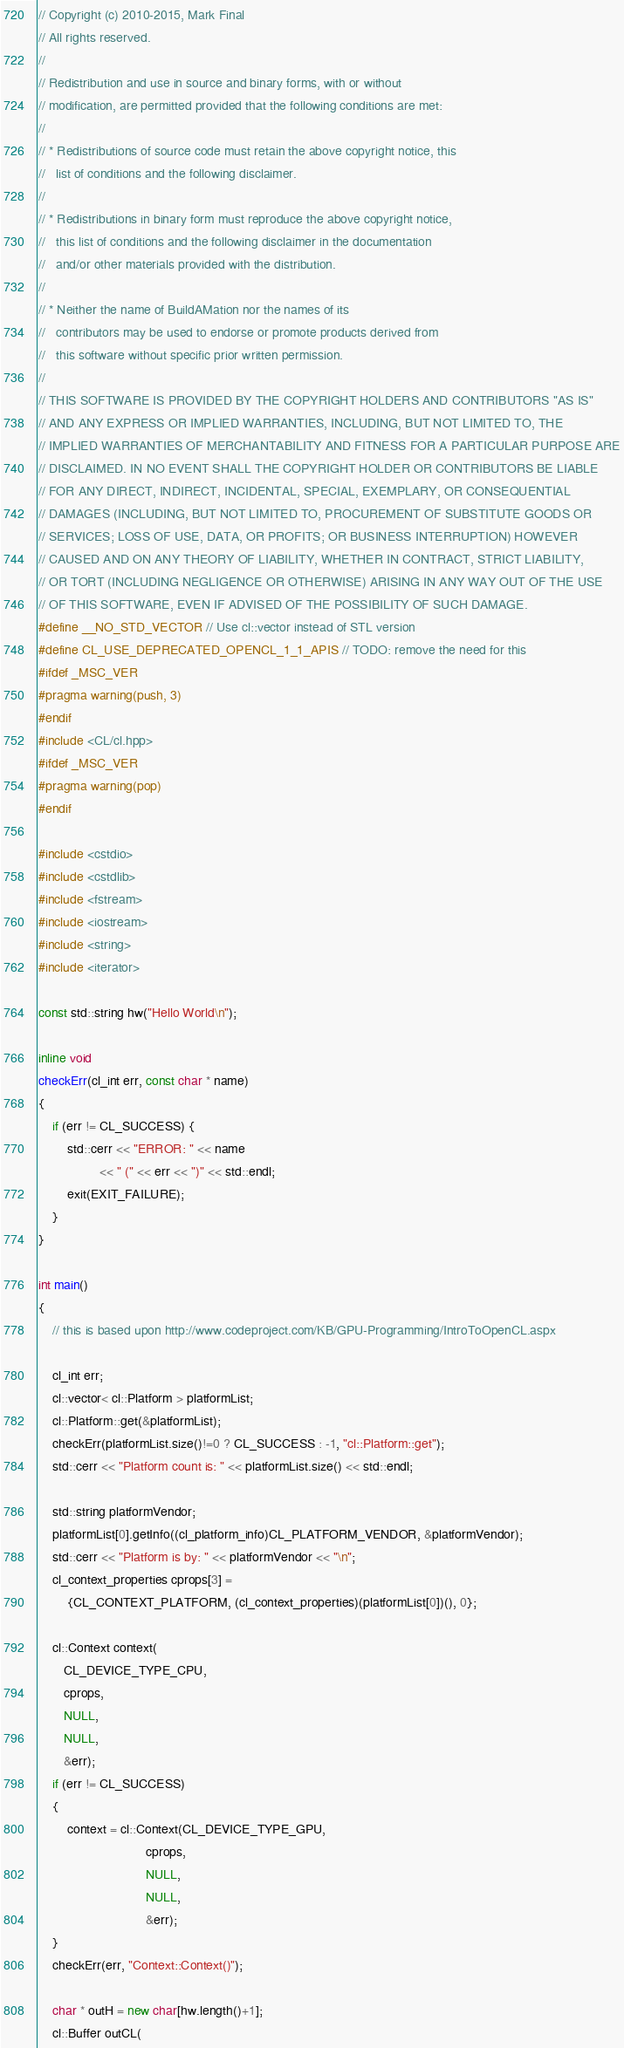Convert code to text. <code><loc_0><loc_0><loc_500><loc_500><_C++_>// Copyright (c) 2010-2015, Mark Final
// All rights reserved.
//
// Redistribution and use in source and binary forms, with or without
// modification, are permitted provided that the following conditions are met:
//
// * Redistributions of source code must retain the above copyright notice, this
//   list of conditions and the following disclaimer.
//
// * Redistributions in binary form must reproduce the above copyright notice,
//   this list of conditions and the following disclaimer in the documentation
//   and/or other materials provided with the distribution.
//
// * Neither the name of BuildAMation nor the names of its
//   contributors may be used to endorse or promote products derived from
//   this software without specific prior written permission.
//
// THIS SOFTWARE IS PROVIDED BY THE COPYRIGHT HOLDERS AND CONTRIBUTORS "AS IS"
// AND ANY EXPRESS OR IMPLIED WARRANTIES, INCLUDING, BUT NOT LIMITED TO, THE
// IMPLIED WARRANTIES OF MERCHANTABILITY AND FITNESS FOR A PARTICULAR PURPOSE ARE
// DISCLAIMED. IN NO EVENT SHALL THE COPYRIGHT HOLDER OR CONTRIBUTORS BE LIABLE
// FOR ANY DIRECT, INDIRECT, INCIDENTAL, SPECIAL, EXEMPLARY, OR CONSEQUENTIAL
// DAMAGES (INCLUDING, BUT NOT LIMITED TO, PROCUREMENT OF SUBSTITUTE GOODS OR
// SERVICES; LOSS OF USE, DATA, OR PROFITS; OR BUSINESS INTERRUPTION) HOWEVER
// CAUSED AND ON ANY THEORY OF LIABILITY, WHETHER IN CONTRACT, STRICT LIABILITY,
// OR TORT (INCLUDING NEGLIGENCE OR OTHERWISE) ARISING IN ANY WAY OUT OF THE USE
// OF THIS SOFTWARE, EVEN IF ADVISED OF THE POSSIBILITY OF SUCH DAMAGE.
#define __NO_STD_VECTOR // Use cl::vector instead of STL version
#define CL_USE_DEPRECATED_OPENCL_1_1_APIS // TODO: remove the need for this
#ifdef _MSC_VER
#pragma warning(push, 3)
#endif
#include <CL/cl.hpp>
#ifdef _MSC_VER
#pragma warning(pop)
#endif

#include <cstdio>
#include <cstdlib>
#include <fstream>
#include <iostream>
#include <string>
#include <iterator>

const std::string hw("Hello World\n");

inline void
checkErr(cl_int err, const char * name)
{
    if (err != CL_SUCCESS) {
        std::cerr << "ERROR: " << name
                 << " (" << err << ")" << std::endl;
        exit(EXIT_FAILURE);
    }
}

int main()
{
    // this is based upon http://www.codeproject.com/KB/GPU-Programming/IntroToOpenCL.aspx

    cl_int err;
    cl::vector< cl::Platform > platformList;
    cl::Platform::get(&platformList);
    checkErr(platformList.size()!=0 ? CL_SUCCESS : -1, "cl::Platform::get");
    std::cerr << "Platform count is: " << platformList.size() << std::endl;

    std::string platformVendor;
    platformList[0].getInfo((cl_platform_info)CL_PLATFORM_VENDOR, &platformVendor);
    std::cerr << "Platform is by: " << platformVendor << "\n";
    cl_context_properties cprops[3] =
        {CL_CONTEXT_PLATFORM, (cl_context_properties)(platformList[0])(), 0};

    cl::Context context(
       CL_DEVICE_TYPE_CPU,
       cprops,
       NULL,
       NULL,
       &err);
    if (err != CL_SUCCESS)
    {
        context = cl::Context(CL_DEVICE_TYPE_GPU,
                              cprops,
                              NULL,
                              NULL,
                              &err);
    }
    checkErr(err, "Context::Context()");

    char * outH = new char[hw.length()+1];
    cl::Buffer outCL(</code> 